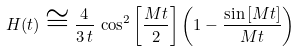<formula> <loc_0><loc_0><loc_500><loc_500>H ( t ) \cong \frac { 4 } { 3 \, t } \, \cos ^ { 2 } { \left [ \frac { M t } { 2 } \right ] } \left ( 1 - \frac { \sin { [ M t ] } } { M t } \right ) \,</formula> 